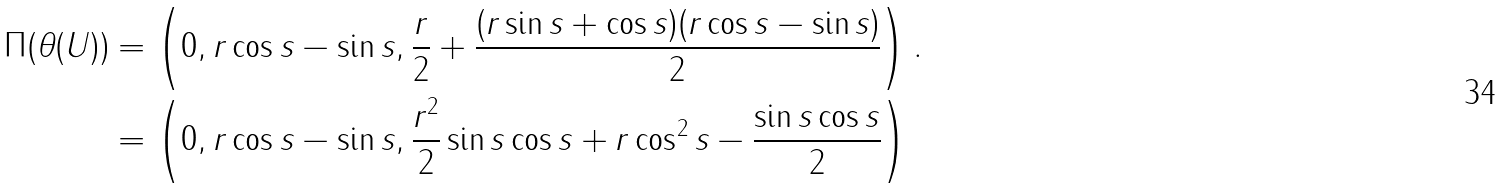Convert formula to latex. <formula><loc_0><loc_0><loc_500><loc_500>\Pi ( \theta ( U ) ) & = \left ( 0 , r \cos s - \sin s , \frac { r } { 2 } + \frac { ( r \sin s + \cos s ) ( r \cos s - \sin s ) } { 2 } \right ) . \\ & = \left ( 0 , r \cos s - \sin s , \frac { r ^ { 2 } } { 2 } \sin s \cos s + r \cos ^ { 2 } s - \frac { \sin s \cos s } { 2 } \right )</formula> 